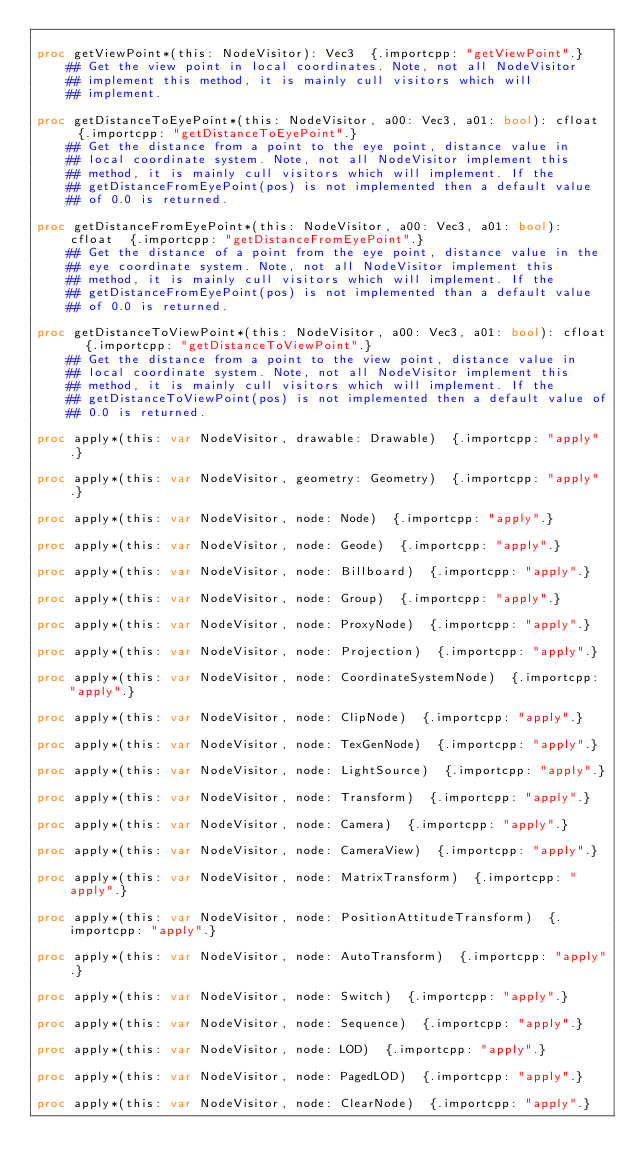<code> <loc_0><loc_0><loc_500><loc_500><_Nim_>
proc getViewPoint*(this: NodeVisitor): Vec3  {.importcpp: "getViewPoint".}
    ## Get the view point in local coordinates. Note, not all NodeVisitor
    ## implement this method, it is mainly cull visitors which will
    ## implement.

proc getDistanceToEyePoint*(this: NodeVisitor, a00: Vec3, a01: bool): cfloat  {.importcpp: "getDistanceToEyePoint".}
    ## Get the distance from a point to the eye point, distance value in
    ## local coordinate system. Note, not all NodeVisitor implement this
    ## method, it is mainly cull visitors which will implement. If the
    ## getDistanceFromEyePoint(pos) is not implemented then a default value
    ## of 0.0 is returned.

proc getDistanceFromEyePoint*(this: NodeVisitor, a00: Vec3, a01: bool): cfloat  {.importcpp: "getDistanceFromEyePoint".}
    ## Get the distance of a point from the eye point, distance value in the
    ## eye coordinate system. Note, not all NodeVisitor implement this
    ## method, it is mainly cull visitors which will implement. If the
    ## getDistanceFromEyePoint(pos) is not implemented than a default value
    ## of 0.0 is returned.

proc getDistanceToViewPoint*(this: NodeVisitor, a00: Vec3, a01: bool): cfloat  {.importcpp: "getDistanceToViewPoint".}
    ## Get the distance from a point to the view point, distance value in
    ## local coordinate system. Note, not all NodeVisitor implement this
    ## method, it is mainly cull visitors which will implement. If the
    ## getDistanceToViewPoint(pos) is not implemented then a default value of
    ## 0.0 is returned.

proc apply*(this: var NodeVisitor, drawable: Drawable)  {.importcpp: "apply".}

proc apply*(this: var NodeVisitor, geometry: Geometry)  {.importcpp: "apply".}

proc apply*(this: var NodeVisitor, node: Node)  {.importcpp: "apply".}

proc apply*(this: var NodeVisitor, node: Geode)  {.importcpp: "apply".}

proc apply*(this: var NodeVisitor, node: Billboard)  {.importcpp: "apply".}

proc apply*(this: var NodeVisitor, node: Group)  {.importcpp: "apply".}

proc apply*(this: var NodeVisitor, node: ProxyNode)  {.importcpp: "apply".}

proc apply*(this: var NodeVisitor, node: Projection)  {.importcpp: "apply".}

proc apply*(this: var NodeVisitor, node: CoordinateSystemNode)  {.importcpp: "apply".}

proc apply*(this: var NodeVisitor, node: ClipNode)  {.importcpp: "apply".}

proc apply*(this: var NodeVisitor, node: TexGenNode)  {.importcpp: "apply".}

proc apply*(this: var NodeVisitor, node: LightSource)  {.importcpp: "apply".}

proc apply*(this: var NodeVisitor, node: Transform)  {.importcpp: "apply".}

proc apply*(this: var NodeVisitor, node: Camera)  {.importcpp: "apply".}

proc apply*(this: var NodeVisitor, node: CameraView)  {.importcpp: "apply".}

proc apply*(this: var NodeVisitor, node: MatrixTransform)  {.importcpp: "apply".}

proc apply*(this: var NodeVisitor, node: PositionAttitudeTransform)  {.importcpp: "apply".}

proc apply*(this: var NodeVisitor, node: AutoTransform)  {.importcpp: "apply".}

proc apply*(this: var NodeVisitor, node: Switch)  {.importcpp: "apply".}

proc apply*(this: var NodeVisitor, node: Sequence)  {.importcpp: "apply".}

proc apply*(this: var NodeVisitor, node: LOD)  {.importcpp: "apply".}

proc apply*(this: var NodeVisitor, node: PagedLOD)  {.importcpp: "apply".}

proc apply*(this: var NodeVisitor, node: ClearNode)  {.importcpp: "apply".}
</code> 